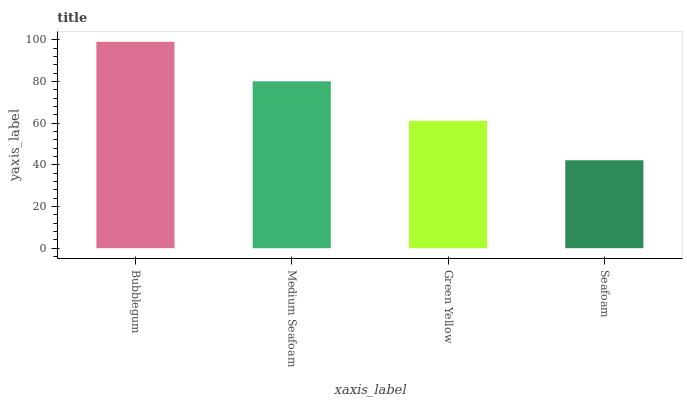Is Medium Seafoam the minimum?
Answer yes or no. No. Is Medium Seafoam the maximum?
Answer yes or no. No. Is Bubblegum greater than Medium Seafoam?
Answer yes or no. Yes. Is Medium Seafoam less than Bubblegum?
Answer yes or no. Yes. Is Medium Seafoam greater than Bubblegum?
Answer yes or no. No. Is Bubblegum less than Medium Seafoam?
Answer yes or no. No. Is Medium Seafoam the high median?
Answer yes or no. Yes. Is Green Yellow the low median?
Answer yes or no. Yes. Is Seafoam the high median?
Answer yes or no. No. Is Seafoam the low median?
Answer yes or no. No. 